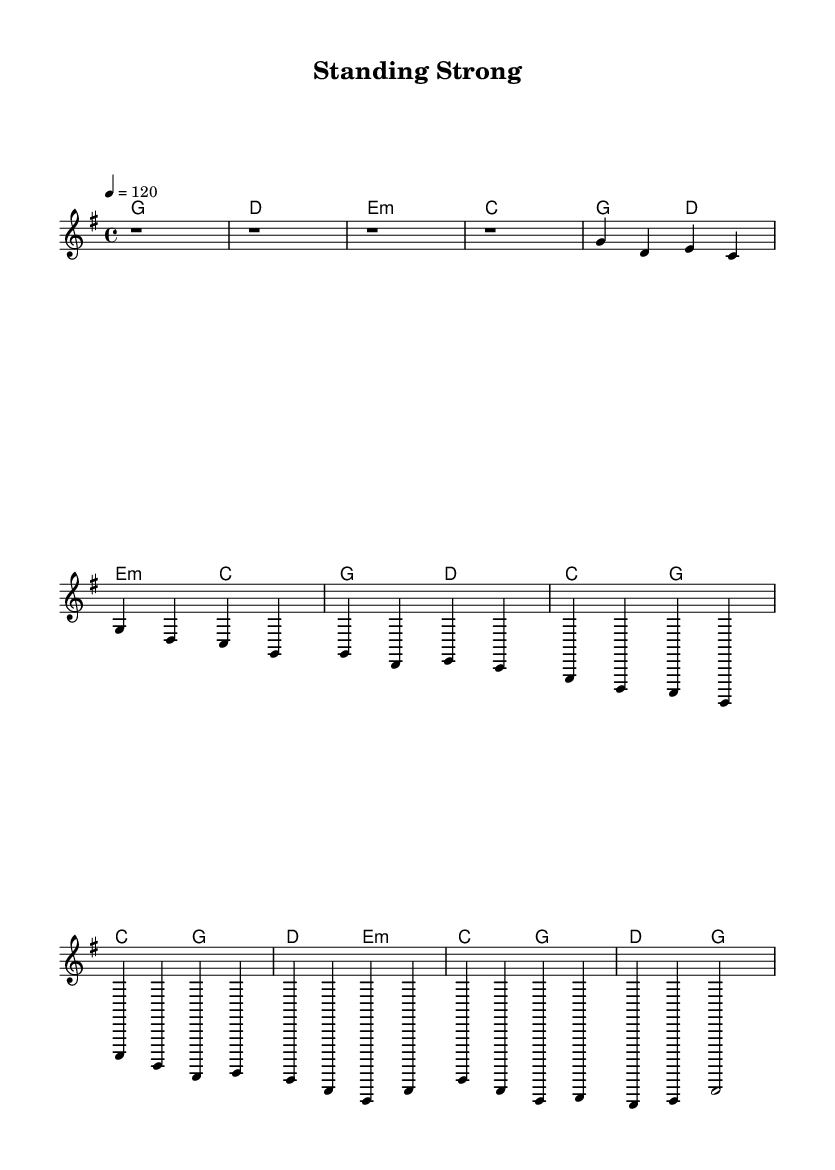What is the key signature of this music? The key signature is G major because it has one sharp (F#), which is indicated on the staff.
Answer: G major What is the time signature of this music? The time signature is 4/4, as indicated at the beginning of the score, meaning there are four beats per measure.
Answer: 4/4 What is the tempo marking of this piece? The tempo marking is 120 beats per minute, as indicated by the symbol "4 = 120" at the start, meaning the quarter note gets 120 beats.
Answer: 120 How many measures does the intro consist of? The intro consists of four measures, as shown in the initial section of the melody with four rest notations.
Answer: 4 What is the first chord of the verse? The first chord of the verse is G major, which is specified in the harmonies section corresponding to the beginning of the melody line.
Answer: G major What type of song structure is used in this piece? The structure used is verse-chorus, as observed in the distinct sections labeled in the melody and harmonies with alternating patterns.
Answer: Verse-Chorus How does the chorus differ from the verse? The chorus features different melodies and harmonies that elevate the emotional intensity, as indicated by the different note sequences and chord progressions in the chorus section.
Answer: Different melodies and harmonies 